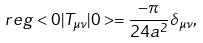<formula> <loc_0><loc_0><loc_500><loc_500>r e g < 0 | T _ { \mu \nu } | 0 > = \frac { - \pi } { 2 4 a ^ { 2 } } \delta _ { \mu \nu } ,</formula> 